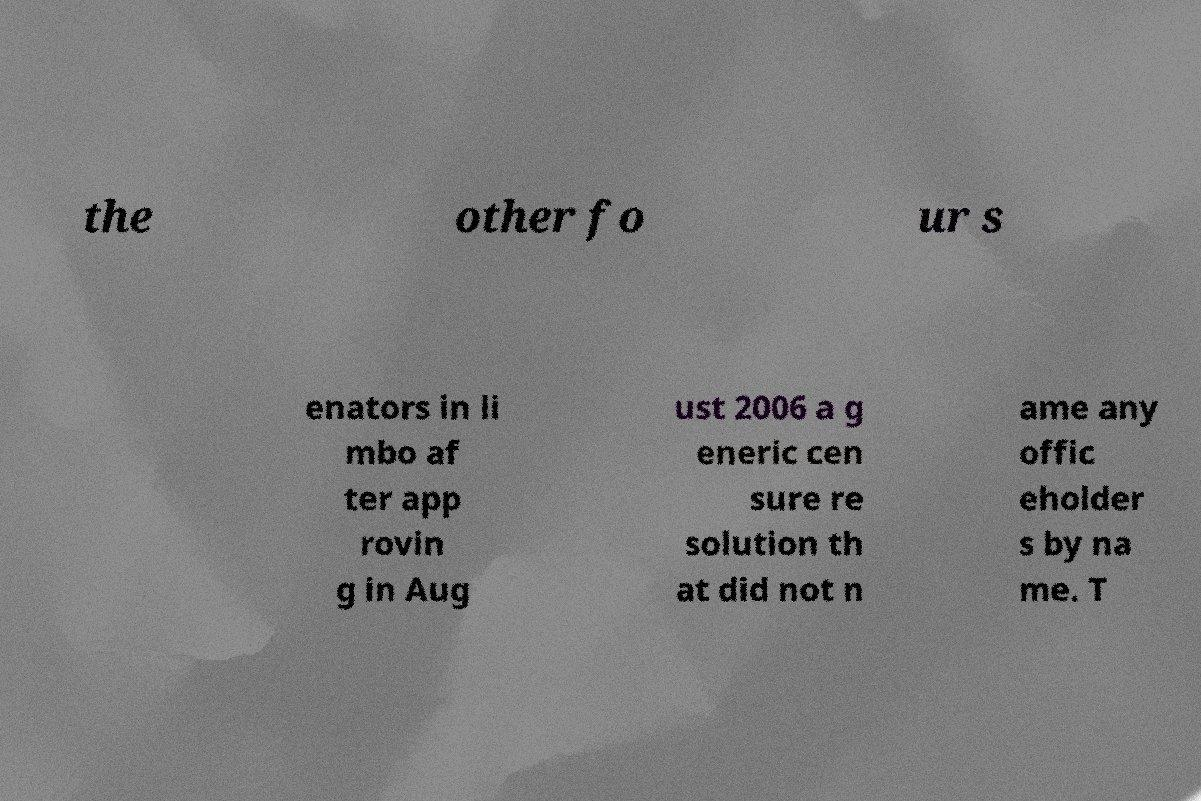Please read and relay the text visible in this image. What does it say? the other fo ur s enators in li mbo af ter app rovin g in Aug ust 2006 a g eneric cen sure re solution th at did not n ame any offic eholder s by na me. T 